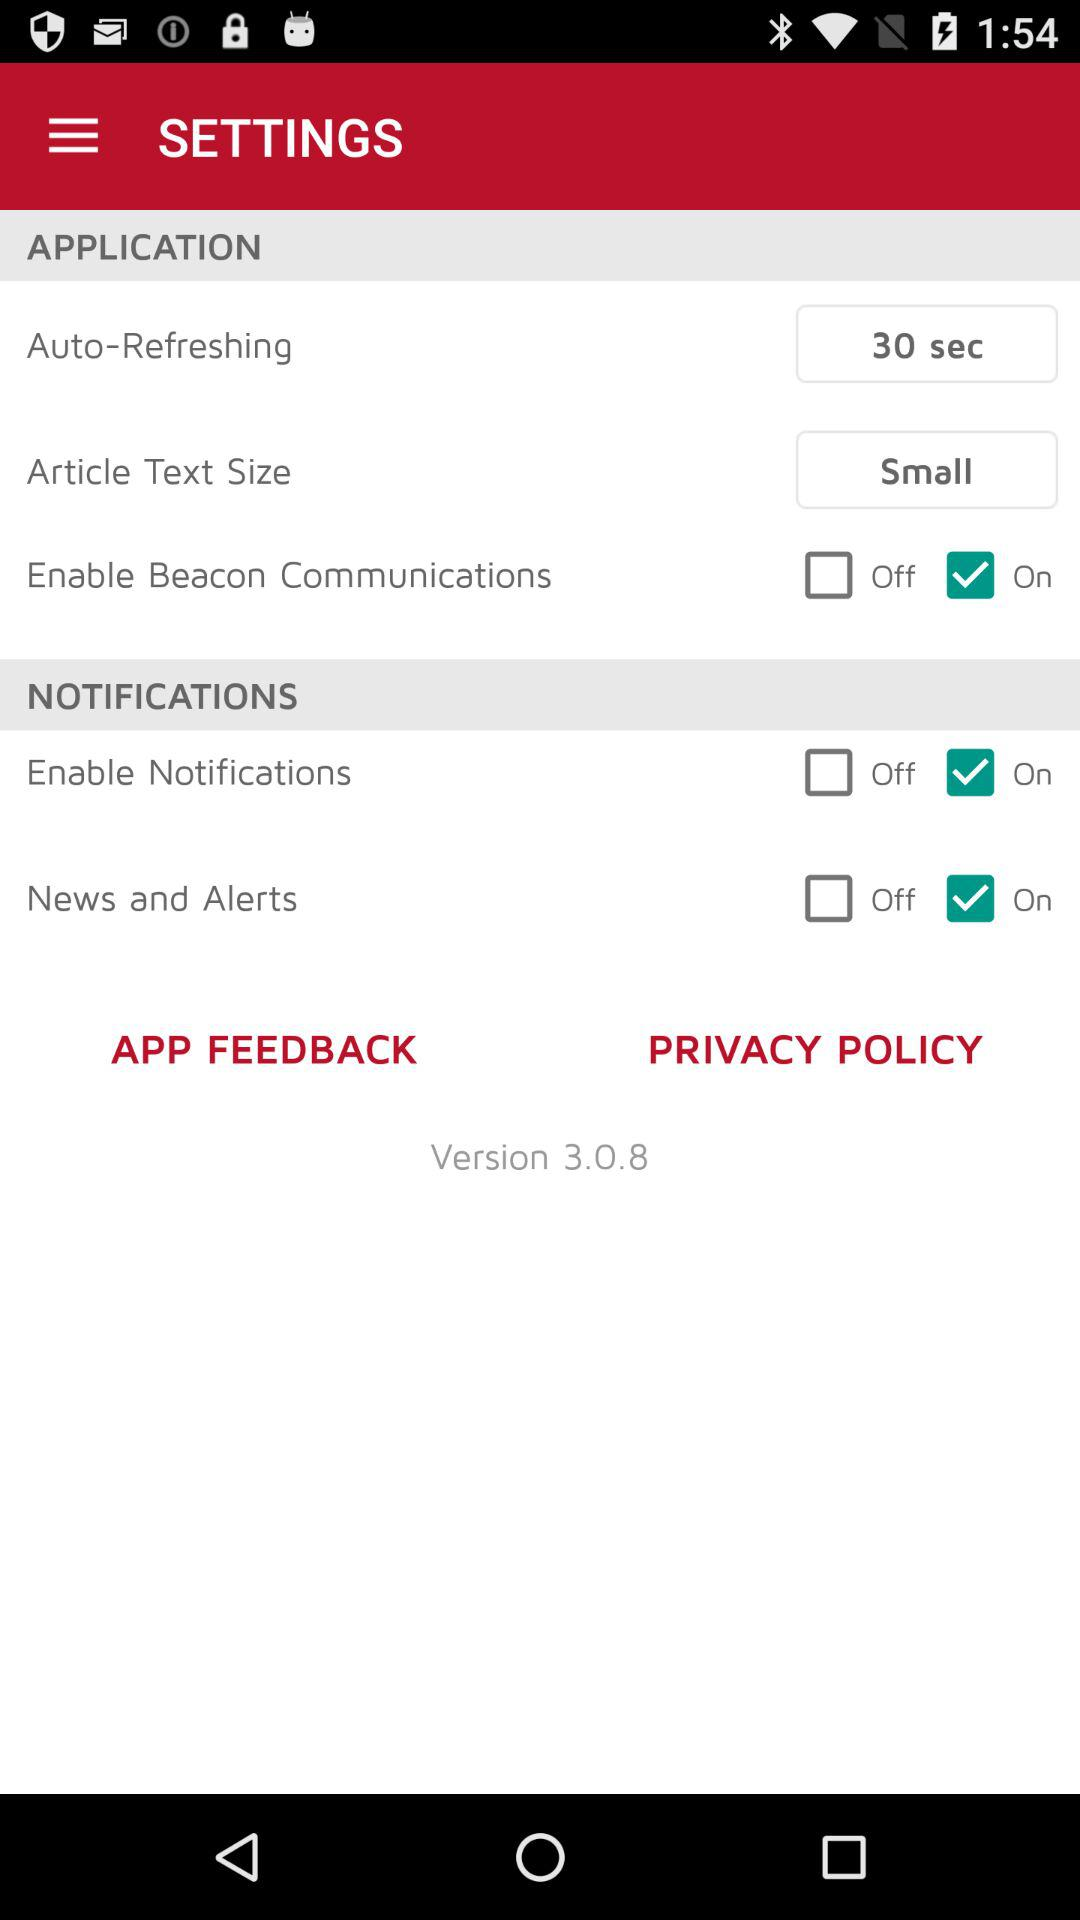What is the status of "Enable Notifications"? The status is "on". 